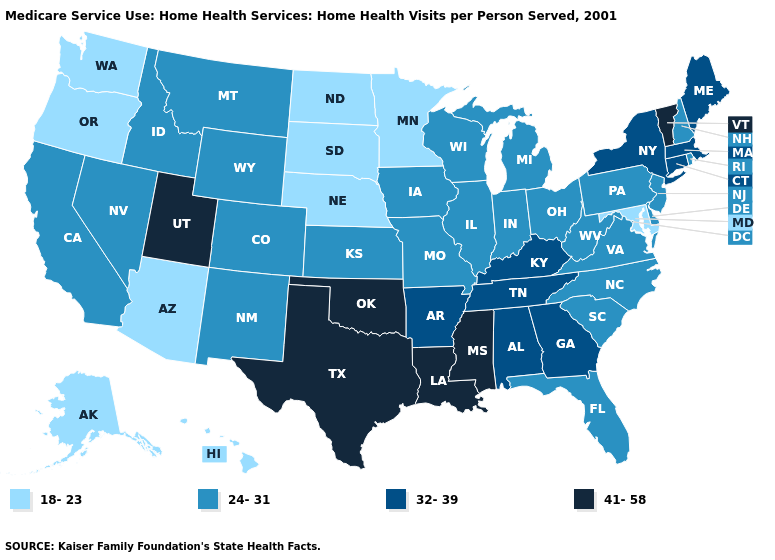Name the states that have a value in the range 32-39?
Write a very short answer. Alabama, Arkansas, Connecticut, Georgia, Kentucky, Maine, Massachusetts, New York, Tennessee. What is the highest value in the West ?
Keep it brief. 41-58. Does Delaware have the lowest value in the USA?
Keep it brief. No. Which states hav the highest value in the MidWest?
Give a very brief answer. Illinois, Indiana, Iowa, Kansas, Michigan, Missouri, Ohio, Wisconsin. What is the value of Tennessee?
Write a very short answer. 32-39. What is the value of Illinois?
Give a very brief answer. 24-31. Name the states that have a value in the range 32-39?
Concise answer only. Alabama, Arkansas, Connecticut, Georgia, Kentucky, Maine, Massachusetts, New York, Tennessee. Among the states that border Alabama , which have the highest value?
Be succinct. Mississippi. What is the highest value in the South ?
Quick response, please. 41-58. What is the value of Montana?
Short answer required. 24-31. Which states hav the highest value in the South?
Be succinct. Louisiana, Mississippi, Oklahoma, Texas. Name the states that have a value in the range 41-58?
Quick response, please. Louisiana, Mississippi, Oklahoma, Texas, Utah, Vermont. Which states have the lowest value in the USA?
Answer briefly. Alaska, Arizona, Hawaii, Maryland, Minnesota, Nebraska, North Dakota, Oregon, South Dakota, Washington. Does Idaho have a lower value than South Dakota?
Give a very brief answer. No. What is the value of Idaho?
Concise answer only. 24-31. 